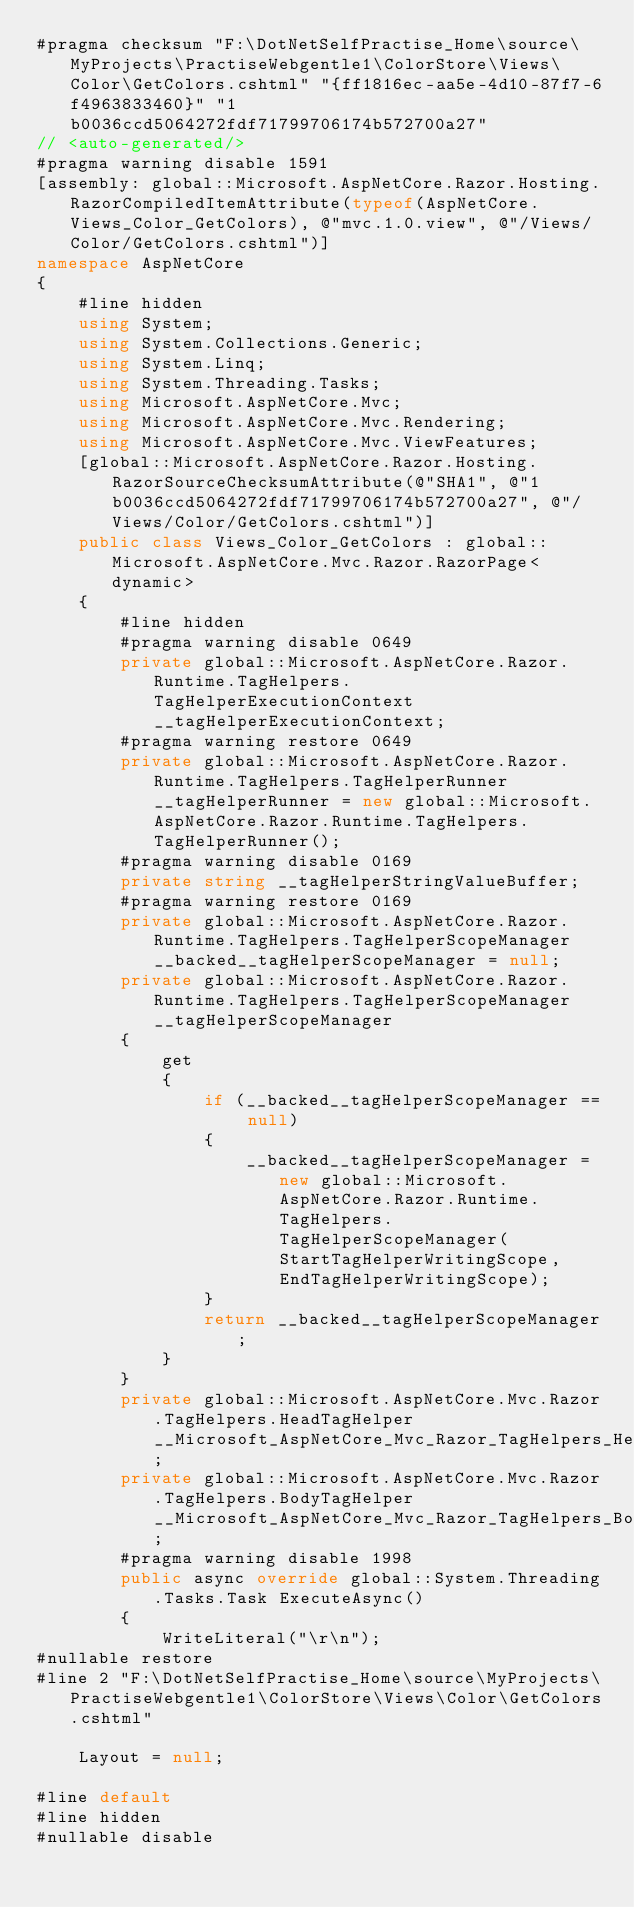<code> <loc_0><loc_0><loc_500><loc_500><_C#_>#pragma checksum "F:\DotNetSelfPractise_Home\source\MyProjects\PractiseWebgentle1\ColorStore\Views\Color\GetColors.cshtml" "{ff1816ec-aa5e-4d10-87f7-6f4963833460}" "1b0036ccd5064272fdf71799706174b572700a27"
// <auto-generated/>
#pragma warning disable 1591
[assembly: global::Microsoft.AspNetCore.Razor.Hosting.RazorCompiledItemAttribute(typeof(AspNetCore.Views_Color_GetColors), @"mvc.1.0.view", @"/Views/Color/GetColors.cshtml")]
namespace AspNetCore
{
    #line hidden
    using System;
    using System.Collections.Generic;
    using System.Linq;
    using System.Threading.Tasks;
    using Microsoft.AspNetCore.Mvc;
    using Microsoft.AspNetCore.Mvc.Rendering;
    using Microsoft.AspNetCore.Mvc.ViewFeatures;
    [global::Microsoft.AspNetCore.Razor.Hosting.RazorSourceChecksumAttribute(@"SHA1", @"1b0036ccd5064272fdf71799706174b572700a27", @"/Views/Color/GetColors.cshtml")]
    public class Views_Color_GetColors : global::Microsoft.AspNetCore.Mvc.Razor.RazorPage<dynamic>
    {
        #line hidden
        #pragma warning disable 0649
        private global::Microsoft.AspNetCore.Razor.Runtime.TagHelpers.TagHelperExecutionContext __tagHelperExecutionContext;
        #pragma warning restore 0649
        private global::Microsoft.AspNetCore.Razor.Runtime.TagHelpers.TagHelperRunner __tagHelperRunner = new global::Microsoft.AspNetCore.Razor.Runtime.TagHelpers.TagHelperRunner();
        #pragma warning disable 0169
        private string __tagHelperStringValueBuffer;
        #pragma warning restore 0169
        private global::Microsoft.AspNetCore.Razor.Runtime.TagHelpers.TagHelperScopeManager __backed__tagHelperScopeManager = null;
        private global::Microsoft.AspNetCore.Razor.Runtime.TagHelpers.TagHelperScopeManager __tagHelperScopeManager
        {
            get
            {
                if (__backed__tagHelperScopeManager == null)
                {
                    __backed__tagHelperScopeManager = new global::Microsoft.AspNetCore.Razor.Runtime.TagHelpers.TagHelperScopeManager(StartTagHelperWritingScope, EndTagHelperWritingScope);
                }
                return __backed__tagHelperScopeManager;
            }
        }
        private global::Microsoft.AspNetCore.Mvc.Razor.TagHelpers.HeadTagHelper __Microsoft_AspNetCore_Mvc_Razor_TagHelpers_HeadTagHelper;
        private global::Microsoft.AspNetCore.Mvc.Razor.TagHelpers.BodyTagHelper __Microsoft_AspNetCore_Mvc_Razor_TagHelpers_BodyTagHelper;
        #pragma warning disable 1998
        public async override global::System.Threading.Tasks.Task ExecuteAsync()
        {
            WriteLiteral("\r\n");
#nullable restore
#line 2 "F:\DotNetSelfPractise_Home\source\MyProjects\PractiseWebgentle1\ColorStore\Views\Color\GetColors.cshtml"
  
    Layout = null;

#line default
#line hidden
#nullable disable</code> 